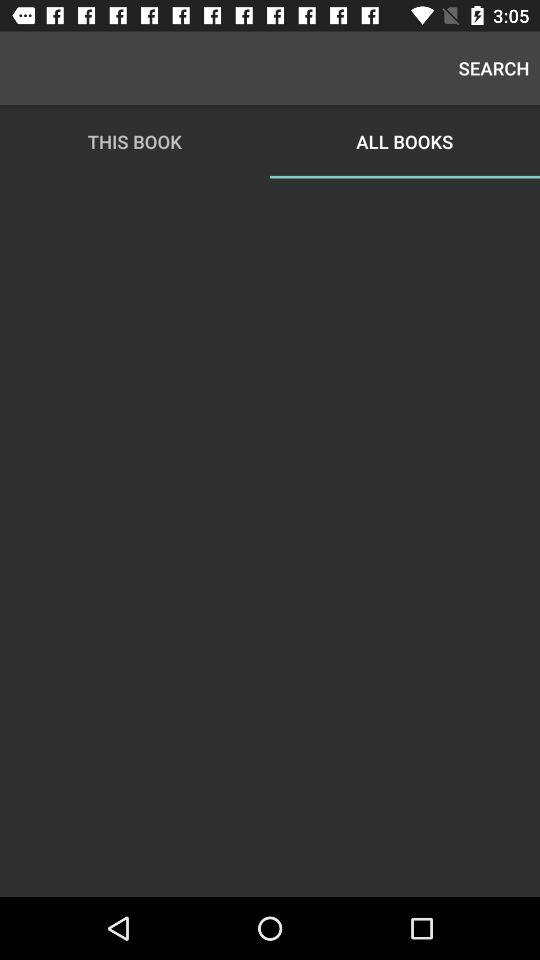Which books are being searched for?
When the provided information is insufficient, respond with <no answer>. <no answer> 